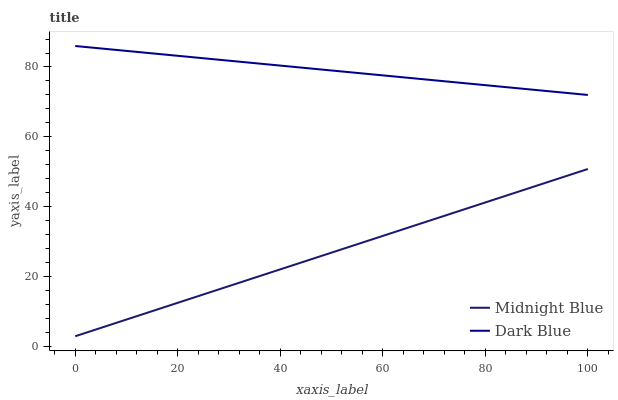Does Midnight Blue have the minimum area under the curve?
Answer yes or no. Yes. Does Dark Blue have the maximum area under the curve?
Answer yes or no. Yes. Does Midnight Blue have the maximum area under the curve?
Answer yes or no. No. Is Midnight Blue the smoothest?
Answer yes or no. Yes. Is Dark Blue the roughest?
Answer yes or no. Yes. Is Midnight Blue the roughest?
Answer yes or no. No. Does Midnight Blue have the lowest value?
Answer yes or no. Yes. Does Dark Blue have the highest value?
Answer yes or no. Yes. Does Midnight Blue have the highest value?
Answer yes or no. No. Is Midnight Blue less than Dark Blue?
Answer yes or no. Yes. Is Dark Blue greater than Midnight Blue?
Answer yes or no. Yes. Does Midnight Blue intersect Dark Blue?
Answer yes or no. No. 